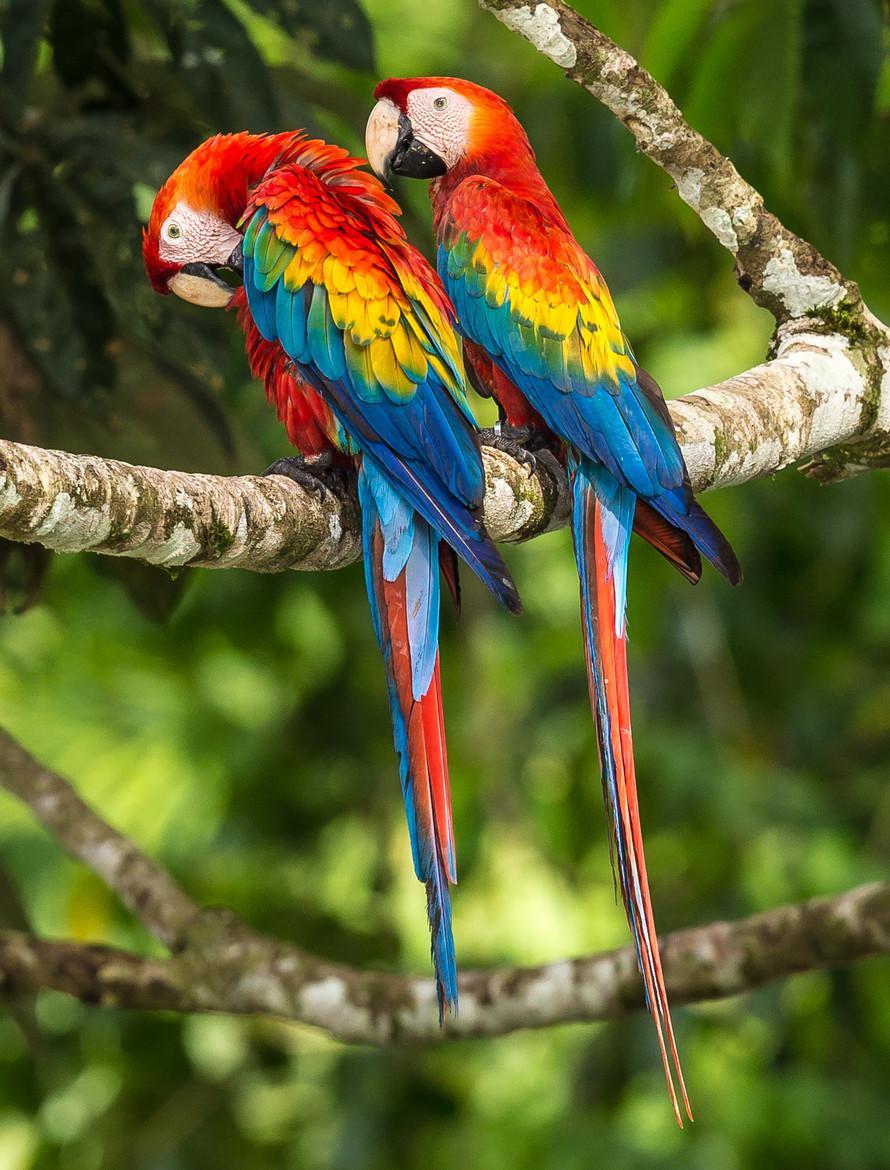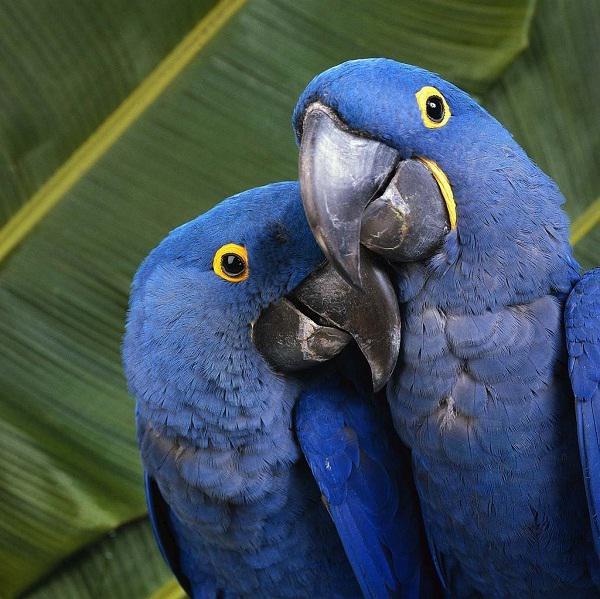The first image is the image on the left, the second image is the image on the right. For the images shown, is this caption "One of the images has two matching solid colored birds standing next to each other on the same branch." true? Answer yes or no. Yes. The first image is the image on the left, the second image is the image on the right. Examine the images to the left and right. Is the description "A blue bird is touching another blue bird." accurate? Answer yes or no. Yes. 